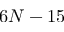Convert formula to latex. <formula><loc_0><loc_0><loc_500><loc_500>6 N - 1 5</formula> 